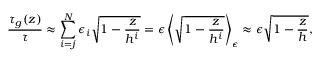Convert formula to latex. <formula><loc_0><loc_0><loc_500><loc_500>\frac { \tau _ { g } ( z ) } { \tau } \approx \sum _ { i = j } ^ { N } \epsilon _ { i } \sqrt { 1 - \frac { z } { h ^ { i } } } = \epsilon \left \langle \sqrt { 1 - \frac { z } { h ^ { i } } } \right \rangle _ { \epsilon } \approx \epsilon \sqrt { 1 - \frac { z } { h } } ,</formula> 